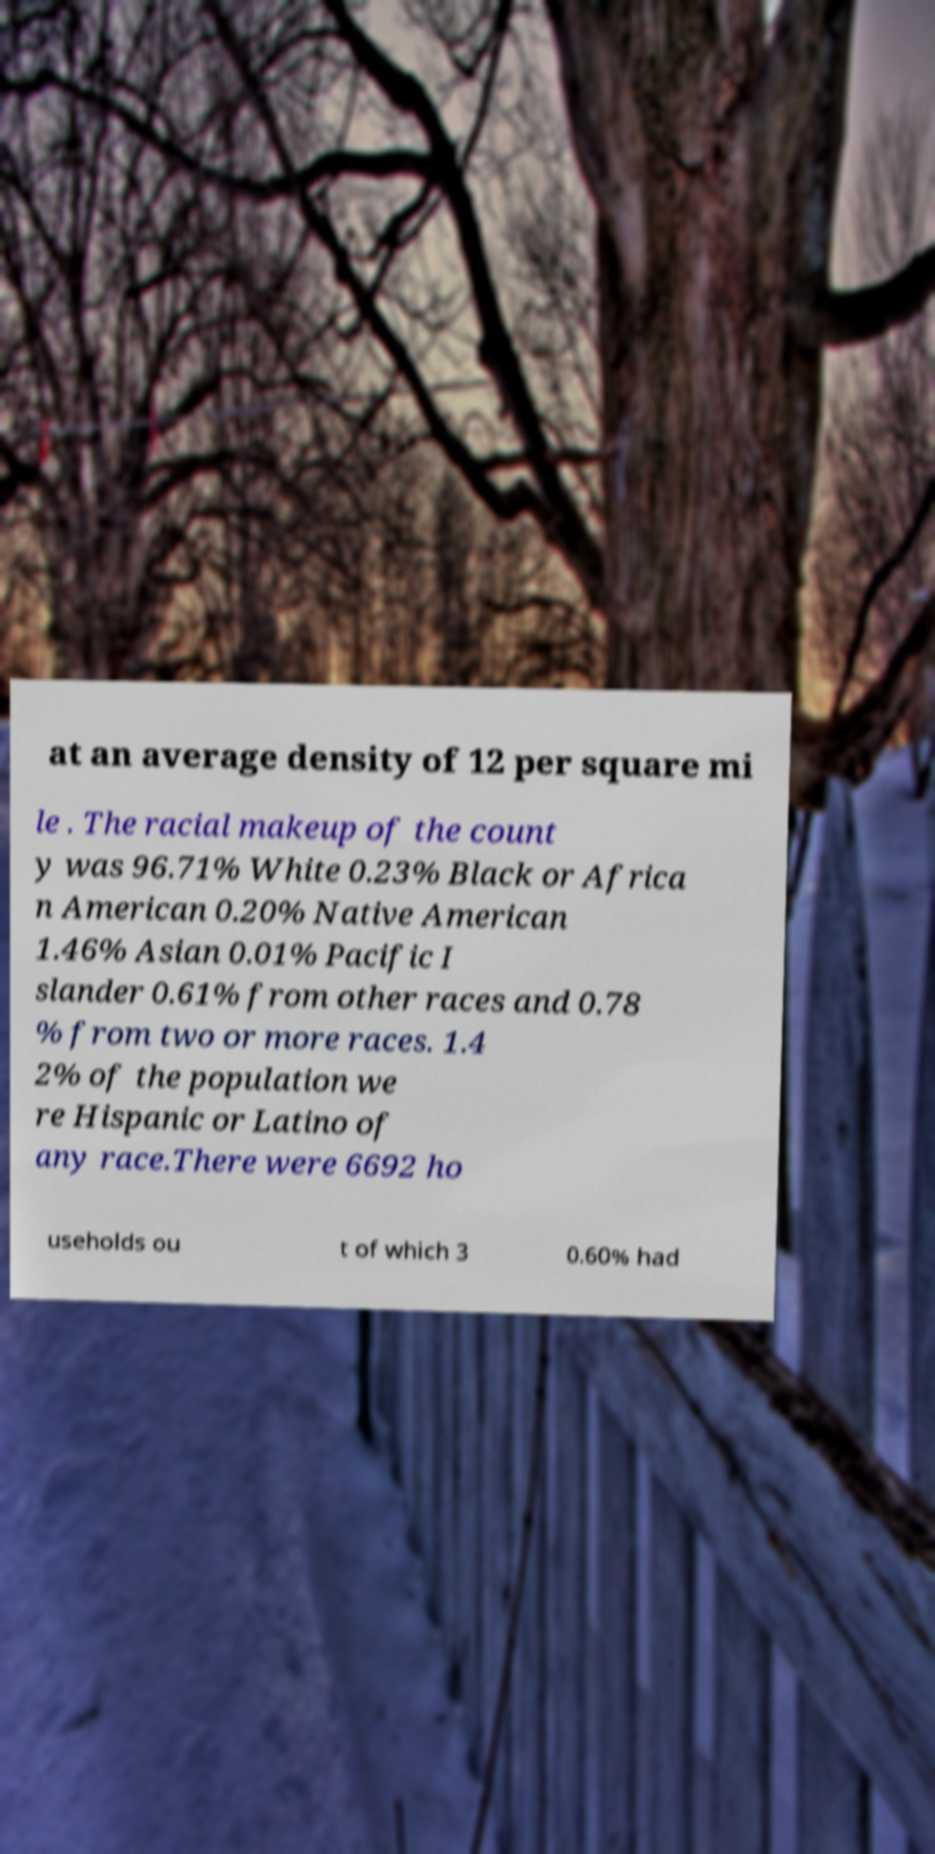Could you assist in decoding the text presented in this image and type it out clearly? at an average density of 12 per square mi le . The racial makeup of the count y was 96.71% White 0.23% Black or Africa n American 0.20% Native American 1.46% Asian 0.01% Pacific I slander 0.61% from other races and 0.78 % from two or more races. 1.4 2% of the population we re Hispanic or Latino of any race.There were 6692 ho useholds ou t of which 3 0.60% had 